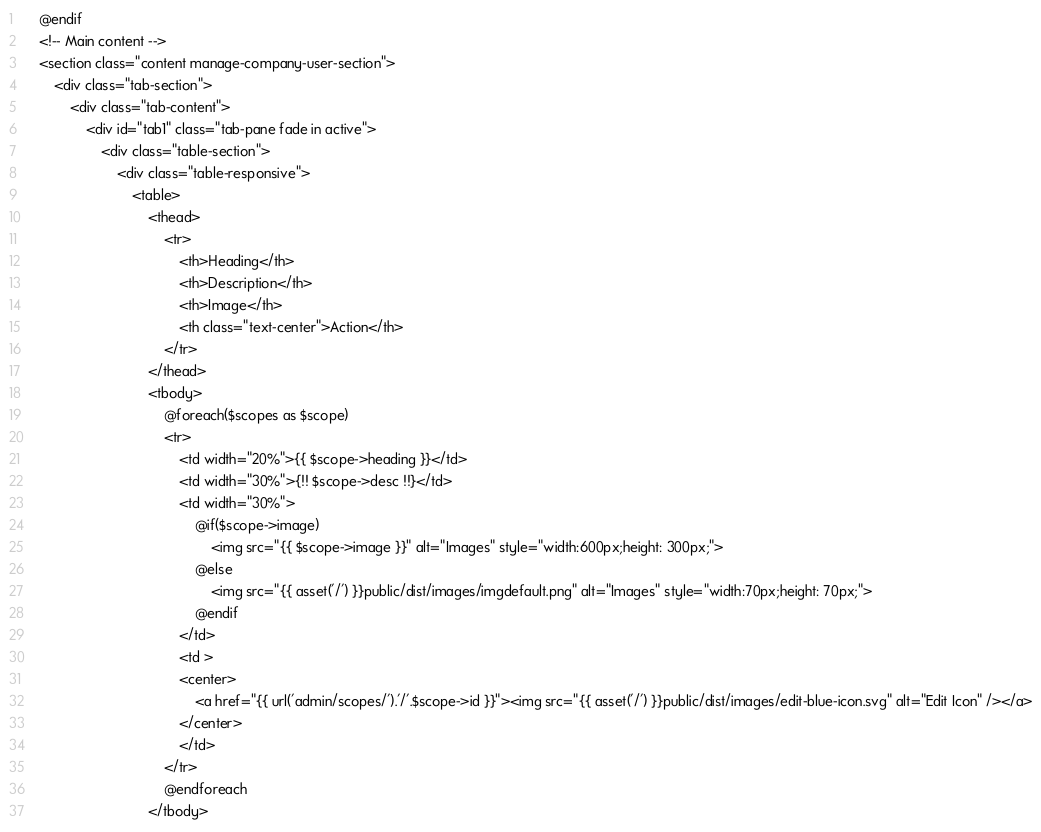Convert code to text. <code><loc_0><loc_0><loc_500><loc_500><_PHP_>    @endif
    <!-- Main content -->
    <section class="content manage-company-user-section">
        <div class="tab-section">
            <div class="tab-content">
                <div id="tab1" class="tab-pane fade in active">
                    <div class="table-section">
                        <div class="table-responsive">
                            <table>
                                <thead>
                                    <tr>
                                        <th>Heading</th>
                                        <th>Description</th>
                                        <th>Image</th>
                                        <th class="text-center">Action</th>
                                    </tr>
                                </thead>
                                <tbody>
                                    @foreach($scopes as $scope)
                                    <tr>
                                        <td width="20%">{{ $scope->heading }}</td>
                                        <td width="30%">{!! $scope->desc !!}</td>
                                        <td width="30%">
                                            @if($scope->image)
                                                <img src="{{ $scope->image }}" alt="Images" style="width:600px;height: 300px;">
                                            @else 
                                                <img src="{{ asset('/') }}public/dist/images/imgdefault.png" alt="Images" style="width:70px;height: 70px;">
                                            @endif
                                        </td>
                                        <td >
                                        <center>
                                            <a href="{{ url('admin/scopes/').'/'.$scope->id }}"><img src="{{ asset('/') }}public/dist/images/edit-blue-icon.svg" alt="Edit Icon" /></a>
                                        </center>
                                        </td>
                                    </tr>
                                    @endforeach
                                </tbody></code> 